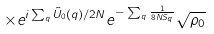<formula> <loc_0><loc_0><loc_500><loc_500>\times e ^ { i \sum _ { q } { \tilde { U } } _ { 0 } ( { q } ) / 2 N } e ^ { - \sum _ { q } \frac { 1 } { 8 N S _ { q } } } \sqrt { \rho _ { 0 } }</formula> 